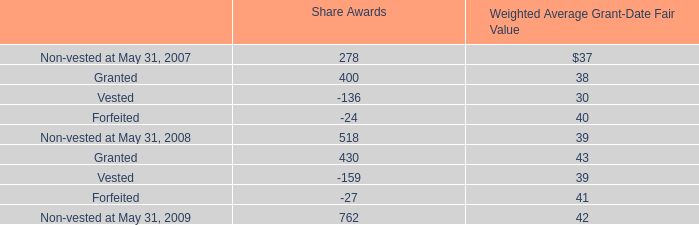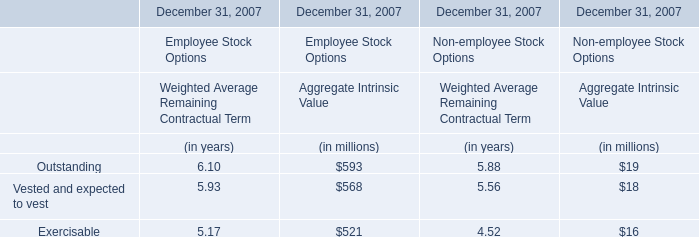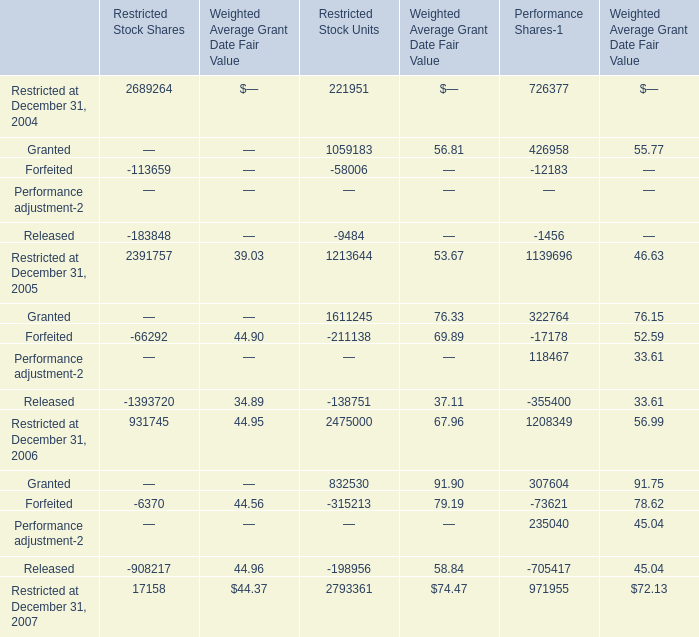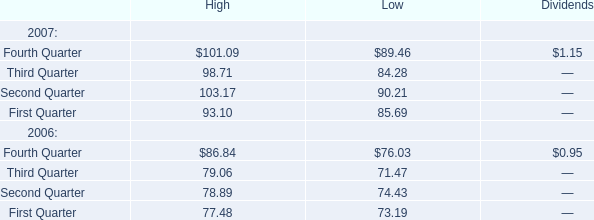Which year is Restricted at December 31, 2005 the highest? 
Answer: 2005. 